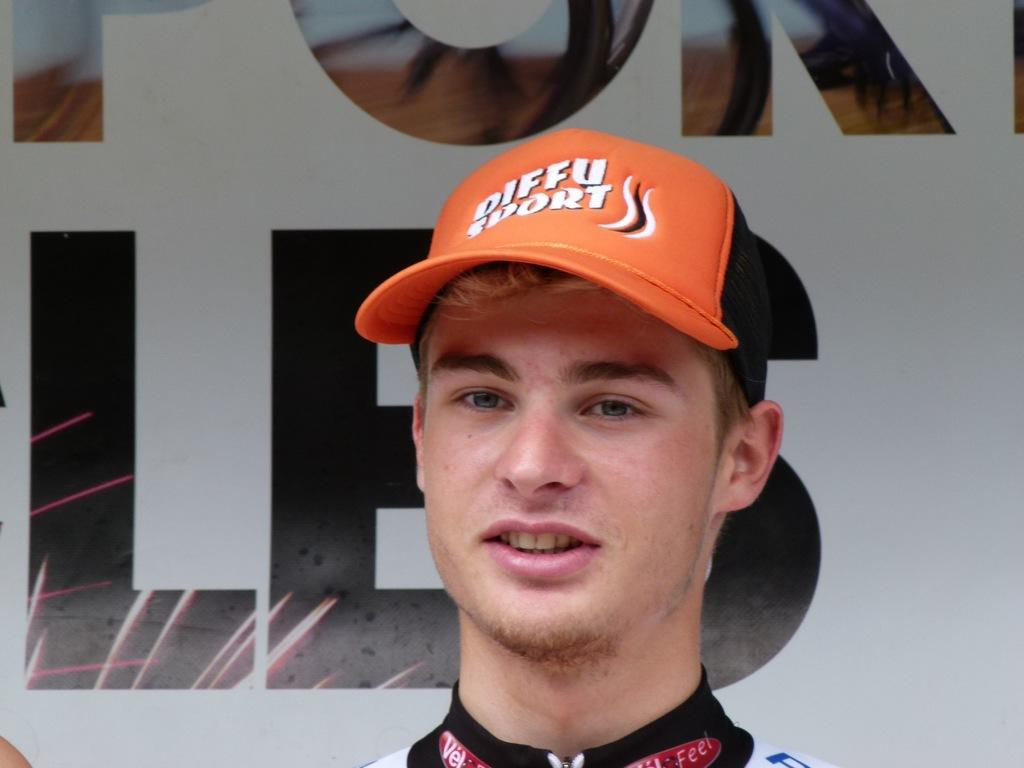Provide a one-sentence caption for the provided image. A young man wear an diffu sports orange baseball hat. 